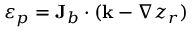Convert formula to latex. <formula><loc_0><loc_0><loc_500><loc_500>\varepsilon _ { p } = { J } _ { b } \cdot ( { k } - \nabla z _ { r } )</formula> 